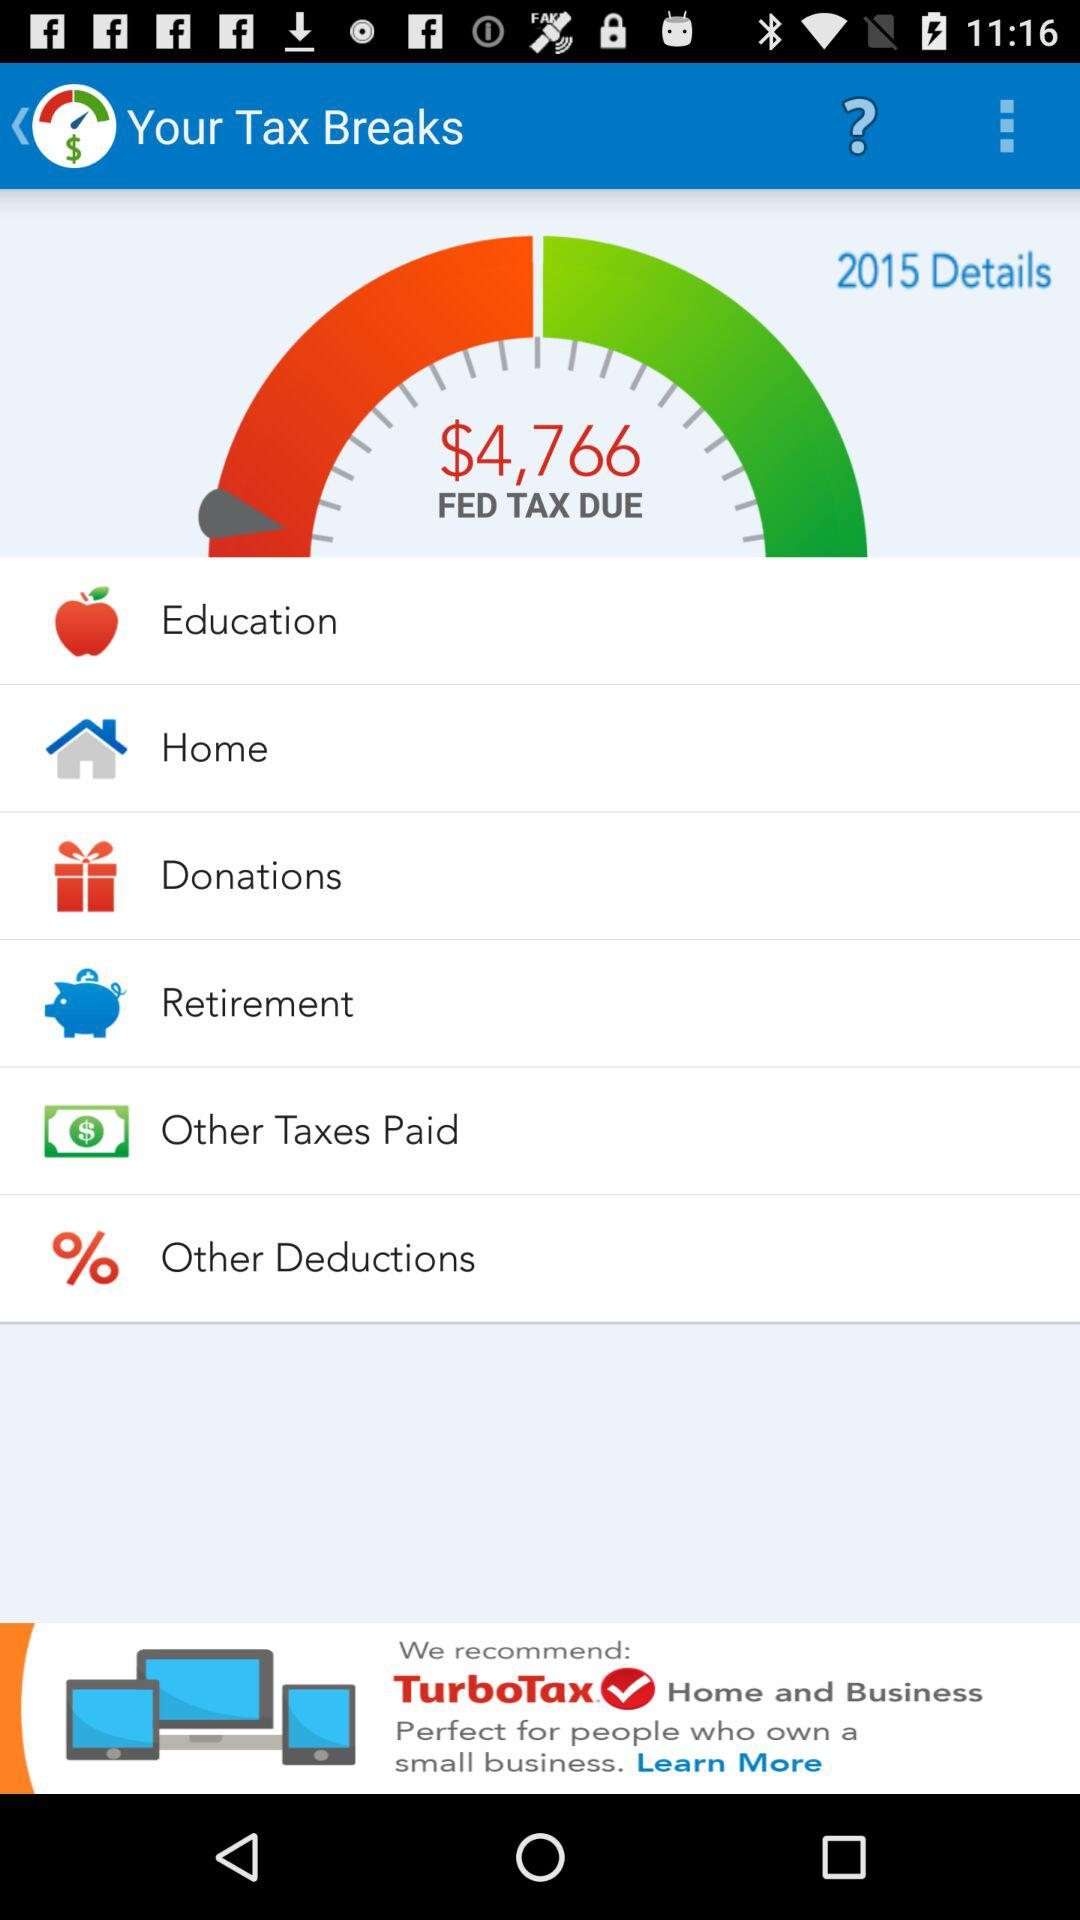What is the amount of the "FED TAX DUE"? The amount is $4,766. 